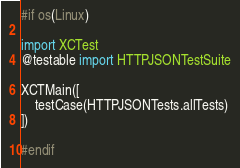<code> <loc_0><loc_0><loc_500><loc_500><_Swift_>#if os(Linux)

import XCTest
@testable import HTTPJSONTestSuite

XCTMain([
    testCase(HTTPJSONTests.allTests)
])

#endif
</code> 